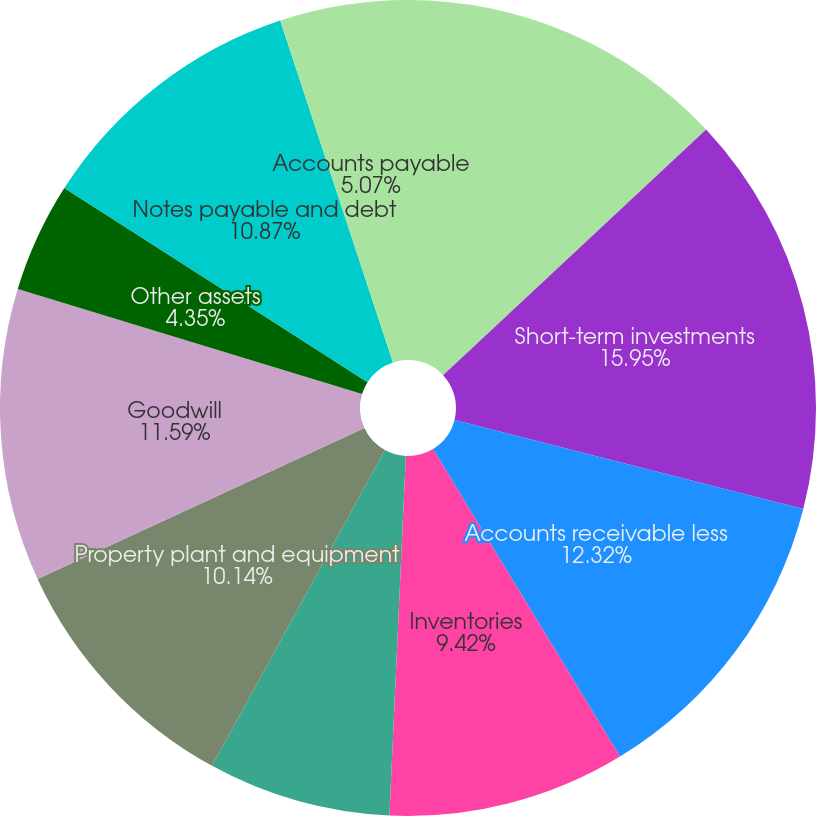Convert chart. <chart><loc_0><loc_0><loc_500><loc_500><pie_chart><fcel>Cash and cash equivalents<fcel>Short-term investments<fcel>Accounts receivable less<fcel>Inventories<fcel>Other current assets<fcel>Property plant and equipment<fcel>Goodwill<fcel>Other assets<fcel>Notes payable and debt<fcel>Accounts payable<nl><fcel>13.04%<fcel>15.94%<fcel>12.32%<fcel>9.42%<fcel>7.25%<fcel>10.14%<fcel>11.59%<fcel>4.35%<fcel>10.87%<fcel>5.07%<nl></chart> 